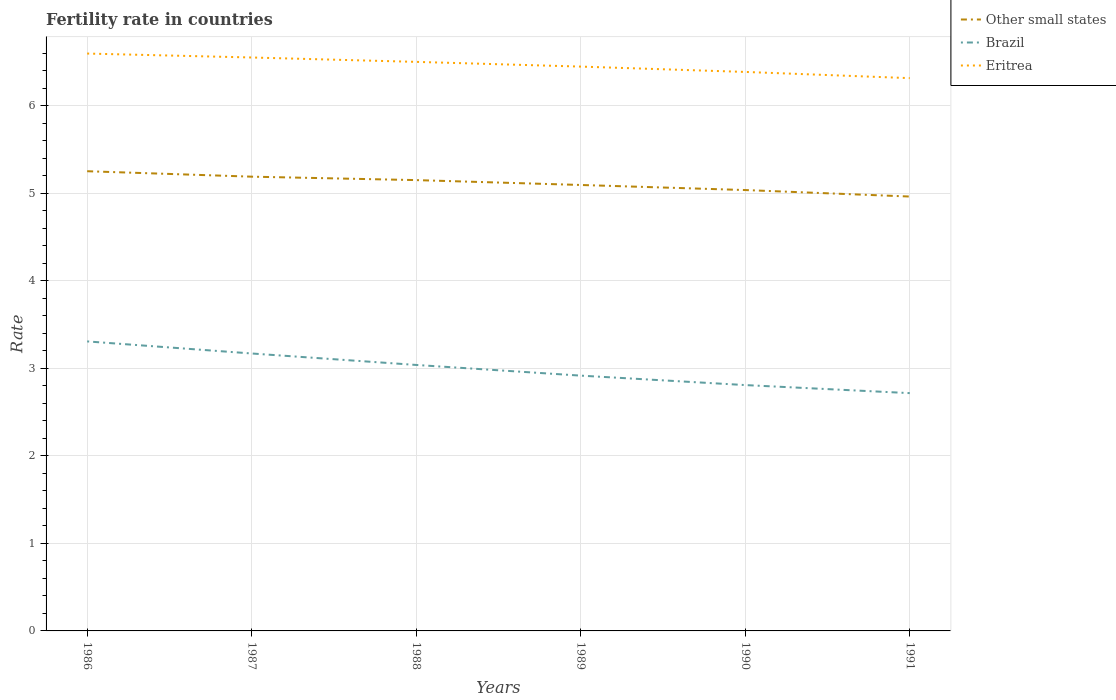Does the line corresponding to Other small states intersect with the line corresponding to Eritrea?
Provide a succinct answer. No. Across all years, what is the maximum fertility rate in Eritrea?
Provide a short and direct response. 6.32. What is the total fertility rate in Eritrea in the graph?
Give a very brief answer. 0.05. What is the difference between the highest and the second highest fertility rate in Brazil?
Your answer should be compact. 0.59. How many lines are there?
Make the answer very short. 3. Does the graph contain grids?
Provide a succinct answer. Yes. How many legend labels are there?
Provide a short and direct response. 3. What is the title of the graph?
Provide a succinct answer. Fertility rate in countries. What is the label or title of the X-axis?
Offer a very short reply. Years. What is the label or title of the Y-axis?
Ensure brevity in your answer.  Rate. What is the Rate of Other small states in 1986?
Ensure brevity in your answer.  5.25. What is the Rate in Brazil in 1986?
Your answer should be very brief. 3.31. What is the Rate in Eritrea in 1986?
Keep it short and to the point. 6.6. What is the Rate of Other small states in 1987?
Your response must be concise. 5.19. What is the Rate in Brazil in 1987?
Provide a succinct answer. 3.17. What is the Rate of Eritrea in 1987?
Offer a terse response. 6.55. What is the Rate of Other small states in 1988?
Offer a terse response. 5.15. What is the Rate of Brazil in 1988?
Offer a very short reply. 3.04. What is the Rate of Eritrea in 1988?
Give a very brief answer. 6.5. What is the Rate in Other small states in 1989?
Your answer should be very brief. 5.1. What is the Rate in Brazil in 1989?
Ensure brevity in your answer.  2.92. What is the Rate in Eritrea in 1989?
Offer a terse response. 6.45. What is the Rate in Other small states in 1990?
Keep it short and to the point. 5.04. What is the Rate of Brazil in 1990?
Give a very brief answer. 2.81. What is the Rate in Eritrea in 1990?
Your response must be concise. 6.39. What is the Rate in Other small states in 1991?
Make the answer very short. 4.96. What is the Rate in Brazil in 1991?
Keep it short and to the point. 2.72. What is the Rate in Eritrea in 1991?
Your answer should be compact. 6.32. Across all years, what is the maximum Rate in Other small states?
Ensure brevity in your answer.  5.25. Across all years, what is the maximum Rate in Brazil?
Your response must be concise. 3.31. Across all years, what is the maximum Rate in Eritrea?
Your answer should be compact. 6.6. Across all years, what is the minimum Rate of Other small states?
Provide a short and direct response. 4.96. Across all years, what is the minimum Rate in Brazil?
Offer a terse response. 2.72. Across all years, what is the minimum Rate in Eritrea?
Provide a short and direct response. 6.32. What is the total Rate in Other small states in the graph?
Your answer should be very brief. 30.69. What is the total Rate in Brazil in the graph?
Your response must be concise. 17.96. What is the total Rate of Eritrea in the graph?
Your answer should be very brief. 38.8. What is the difference between the Rate in Other small states in 1986 and that in 1987?
Your answer should be very brief. 0.06. What is the difference between the Rate of Brazil in 1986 and that in 1987?
Your answer should be very brief. 0.14. What is the difference between the Rate of Eritrea in 1986 and that in 1987?
Offer a very short reply. 0.04. What is the difference between the Rate in Other small states in 1986 and that in 1988?
Offer a very short reply. 0.1. What is the difference between the Rate of Brazil in 1986 and that in 1988?
Give a very brief answer. 0.27. What is the difference between the Rate in Eritrea in 1986 and that in 1988?
Your answer should be compact. 0.1. What is the difference between the Rate of Other small states in 1986 and that in 1989?
Offer a terse response. 0.16. What is the difference between the Rate in Brazil in 1986 and that in 1989?
Provide a succinct answer. 0.39. What is the difference between the Rate in Eritrea in 1986 and that in 1989?
Your response must be concise. 0.15. What is the difference between the Rate of Other small states in 1986 and that in 1990?
Provide a succinct answer. 0.22. What is the difference between the Rate of Brazil in 1986 and that in 1990?
Provide a succinct answer. 0.5. What is the difference between the Rate of Eritrea in 1986 and that in 1990?
Provide a short and direct response. 0.21. What is the difference between the Rate in Other small states in 1986 and that in 1991?
Your answer should be very brief. 0.29. What is the difference between the Rate of Brazil in 1986 and that in 1991?
Your answer should be compact. 0.59. What is the difference between the Rate of Eritrea in 1986 and that in 1991?
Your answer should be compact. 0.28. What is the difference between the Rate in Other small states in 1987 and that in 1988?
Provide a succinct answer. 0.04. What is the difference between the Rate of Brazil in 1987 and that in 1988?
Your response must be concise. 0.13. What is the difference between the Rate of Other small states in 1987 and that in 1989?
Keep it short and to the point. 0.09. What is the difference between the Rate in Brazil in 1987 and that in 1989?
Offer a terse response. 0.25. What is the difference between the Rate in Eritrea in 1987 and that in 1989?
Ensure brevity in your answer.  0.1. What is the difference between the Rate in Other small states in 1987 and that in 1990?
Make the answer very short. 0.15. What is the difference between the Rate of Brazil in 1987 and that in 1990?
Give a very brief answer. 0.36. What is the difference between the Rate of Eritrea in 1987 and that in 1990?
Your answer should be compact. 0.17. What is the difference between the Rate in Other small states in 1987 and that in 1991?
Provide a short and direct response. 0.23. What is the difference between the Rate of Brazil in 1987 and that in 1991?
Provide a short and direct response. 0.45. What is the difference between the Rate of Eritrea in 1987 and that in 1991?
Your response must be concise. 0.24. What is the difference between the Rate of Other small states in 1988 and that in 1989?
Your answer should be compact. 0.06. What is the difference between the Rate in Brazil in 1988 and that in 1989?
Your response must be concise. 0.12. What is the difference between the Rate in Eritrea in 1988 and that in 1989?
Give a very brief answer. 0.05. What is the difference between the Rate of Other small states in 1988 and that in 1990?
Your response must be concise. 0.11. What is the difference between the Rate of Brazil in 1988 and that in 1990?
Give a very brief answer. 0.23. What is the difference between the Rate of Eritrea in 1988 and that in 1990?
Give a very brief answer. 0.12. What is the difference between the Rate in Other small states in 1988 and that in 1991?
Give a very brief answer. 0.19. What is the difference between the Rate of Brazil in 1988 and that in 1991?
Offer a terse response. 0.32. What is the difference between the Rate of Eritrea in 1988 and that in 1991?
Give a very brief answer. 0.19. What is the difference between the Rate of Other small states in 1989 and that in 1990?
Provide a succinct answer. 0.06. What is the difference between the Rate of Brazil in 1989 and that in 1990?
Provide a succinct answer. 0.11. What is the difference between the Rate in Eritrea in 1989 and that in 1990?
Your answer should be very brief. 0.06. What is the difference between the Rate in Other small states in 1989 and that in 1991?
Offer a very short reply. 0.13. What is the difference between the Rate in Brazil in 1989 and that in 1991?
Offer a very short reply. 0.2. What is the difference between the Rate in Eritrea in 1989 and that in 1991?
Your answer should be very brief. 0.13. What is the difference between the Rate in Other small states in 1990 and that in 1991?
Your answer should be very brief. 0.07. What is the difference between the Rate in Brazil in 1990 and that in 1991?
Ensure brevity in your answer.  0.09. What is the difference between the Rate of Eritrea in 1990 and that in 1991?
Your answer should be very brief. 0.07. What is the difference between the Rate in Other small states in 1986 and the Rate in Brazil in 1987?
Make the answer very short. 2.08. What is the difference between the Rate of Other small states in 1986 and the Rate of Eritrea in 1987?
Provide a short and direct response. -1.3. What is the difference between the Rate in Brazil in 1986 and the Rate in Eritrea in 1987?
Your answer should be very brief. -3.24. What is the difference between the Rate of Other small states in 1986 and the Rate of Brazil in 1988?
Make the answer very short. 2.21. What is the difference between the Rate in Other small states in 1986 and the Rate in Eritrea in 1988?
Offer a terse response. -1.25. What is the difference between the Rate of Brazil in 1986 and the Rate of Eritrea in 1988?
Keep it short and to the point. -3.19. What is the difference between the Rate in Other small states in 1986 and the Rate in Brazil in 1989?
Your response must be concise. 2.34. What is the difference between the Rate of Other small states in 1986 and the Rate of Eritrea in 1989?
Your answer should be very brief. -1.2. What is the difference between the Rate of Brazil in 1986 and the Rate of Eritrea in 1989?
Your answer should be compact. -3.14. What is the difference between the Rate in Other small states in 1986 and the Rate in Brazil in 1990?
Your answer should be very brief. 2.44. What is the difference between the Rate in Other small states in 1986 and the Rate in Eritrea in 1990?
Your answer should be very brief. -1.13. What is the difference between the Rate of Brazil in 1986 and the Rate of Eritrea in 1990?
Provide a succinct answer. -3.08. What is the difference between the Rate in Other small states in 1986 and the Rate in Brazil in 1991?
Provide a succinct answer. 2.54. What is the difference between the Rate of Other small states in 1986 and the Rate of Eritrea in 1991?
Offer a very short reply. -1.06. What is the difference between the Rate in Brazil in 1986 and the Rate in Eritrea in 1991?
Provide a succinct answer. -3.01. What is the difference between the Rate in Other small states in 1987 and the Rate in Brazil in 1988?
Ensure brevity in your answer.  2.15. What is the difference between the Rate of Other small states in 1987 and the Rate of Eritrea in 1988?
Make the answer very short. -1.31. What is the difference between the Rate of Brazil in 1987 and the Rate of Eritrea in 1988?
Offer a very short reply. -3.33. What is the difference between the Rate in Other small states in 1987 and the Rate in Brazil in 1989?
Give a very brief answer. 2.27. What is the difference between the Rate in Other small states in 1987 and the Rate in Eritrea in 1989?
Ensure brevity in your answer.  -1.26. What is the difference between the Rate in Brazil in 1987 and the Rate in Eritrea in 1989?
Give a very brief answer. -3.28. What is the difference between the Rate of Other small states in 1987 and the Rate of Brazil in 1990?
Your answer should be compact. 2.38. What is the difference between the Rate of Other small states in 1987 and the Rate of Eritrea in 1990?
Provide a short and direct response. -1.2. What is the difference between the Rate in Brazil in 1987 and the Rate in Eritrea in 1990?
Offer a terse response. -3.22. What is the difference between the Rate in Other small states in 1987 and the Rate in Brazil in 1991?
Your answer should be very brief. 2.47. What is the difference between the Rate of Other small states in 1987 and the Rate of Eritrea in 1991?
Provide a short and direct response. -1.13. What is the difference between the Rate in Brazil in 1987 and the Rate in Eritrea in 1991?
Keep it short and to the point. -3.15. What is the difference between the Rate in Other small states in 1988 and the Rate in Brazil in 1989?
Give a very brief answer. 2.23. What is the difference between the Rate of Other small states in 1988 and the Rate of Eritrea in 1989?
Your answer should be very brief. -1.3. What is the difference between the Rate of Brazil in 1988 and the Rate of Eritrea in 1989?
Provide a short and direct response. -3.41. What is the difference between the Rate in Other small states in 1988 and the Rate in Brazil in 1990?
Provide a succinct answer. 2.34. What is the difference between the Rate in Other small states in 1988 and the Rate in Eritrea in 1990?
Offer a terse response. -1.24. What is the difference between the Rate of Brazil in 1988 and the Rate of Eritrea in 1990?
Provide a succinct answer. -3.35. What is the difference between the Rate of Other small states in 1988 and the Rate of Brazil in 1991?
Ensure brevity in your answer.  2.43. What is the difference between the Rate of Other small states in 1988 and the Rate of Eritrea in 1991?
Offer a terse response. -1.17. What is the difference between the Rate in Brazil in 1988 and the Rate in Eritrea in 1991?
Provide a succinct answer. -3.28. What is the difference between the Rate in Other small states in 1989 and the Rate in Brazil in 1990?
Ensure brevity in your answer.  2.29. What is the difference between the Rate of Other small states in 1989 and the Rate of Eritrea in 1990?
Offer a terse response. -1.29. What is the difference between the Rate of Brazil in 1989 and the Rate of Eritrea in 1990?
Provide a short and direct response. -3.47. What is the difference between the Rate in Other small states in 1989 and the Rate in Brazil in 1991?
Your answer should be very brief. 2.38. What is the difference between the Rate in Other small states in 1989 and the Rate in Eritrea in 1991?
Your answer should be compact. -1.22. What is the difference between the Rate in Brazil in 1989 and the Rate in Eritrea in 1991?
Ensure brevity in your answer.  -3.4. What is the difference between the Rate in Other small states in 1990 and the Rate in Brazil in 1991?
Your response must be concise. 2.32. What is the difference between the Rate of Other small states in 1990 and the Rate of Eritrea in 1991?
Offer a very short reply. -1.28. What is the difference between the Rate in Brazil in 1990 and the Rate in Eritrea in 1991?
Ensure brevity in your answer.  -3.51. What is the average Rate of Other small states per year?
Offer a terse response. 5.12. What is the average Rate in Brazil per year?
Offer a terse response. 2.99. What is the average Rate of Eritrea per year?
Provide a succinct answer. 6.47. In the year 1986, what is the difference between the Rate of Other small states and Rate of Brazil?
Keep it short and to the point. 1.94. In the year 1986, what is the difference between the Rate in Other small states and Rate in Eritrea?
Your response must be concise. -1.34. In the year 1986, what is the difference between the Rate in Brazil and Rate in Eritrea?
Make the answer very short. -3.29. In the year 1987, what is the difference between the Rate in Other small states and Rate in Brazil?
Provide a short and direct response. 2.02. In the year 1987, what is the difference between the Rate in Other small states and Rate in Eritrea?
Provide a succinct answer. -1.36. In the year 1987, what is the difference between the Rate of Brazil and Rate of Eritrea?
Provide a short and direct response. -3.38. In the year 1988, what is the difference between the Rate of Other small states and Rate of Brazil?
Provide a short and direct response. 2.11. In the year 1988, what is the difference between the Rate of Other small states and Rate of Eritrea?
Keep it short and to the point. -1.35. In the year 1988, what is the difference between the Rate in Brazil and Rate in Eritrea?
Offer a terse response. -3.46. In the year 1989, what is the difference between the Rate of Other small states and Rate of Brazil?
Keep it short and to the point. 2.18. In the year 1989, what is the difference between the Rate of Other small states and Rate of Eritrea?
Ensure brevity in your answer.  -1.35. In the year 1989, what is the difference between the Rate of Brazil and Rate of Eritrea?
Ensure brevity in your answer.  -3.53. In the year 1990, what is the difference between the Rate of Other small states and Rate of Brazil?
Give a very brief answer. 2.23. In the year 1990, what is the difference between the Rate of Other small states and Rate of Eritrea?
Make the answer very short. -1.35. In the year 1990, what is the difference between the Rate in Brazil and Rate in Eritrea?
Your answer should be compact. -3.58. In the year 1991, what is the difference between the Rate of Other small states and Rate of Brazil?
Your answer should be very brief. 2.25. In the year 1991, what is the difference between the Rate of Other small states and Rate of Eritrea?
Your answer should be compact. -1.35. In the year 1991, what is the difference between the Rate in Brazil and Rate in Eritrea?
Give a very brief answer. -3.6. What is the ratio of the Rate of Other small states in 1986 to that in 1987?
Offer a very short reply. 1.01. What is the ratio of the Rate in Brazil in 1986 to that in 1987?
Your response must be concise. 1.04. What is the ratio of the Rate in Other small states in 1986 to that in 1988?
Ensure brevity in your answer.  1.02. What is the ratio of the Rate of Brazil in 1986 to that in 1988?
Give a very brief answer. 1.09. What is the ratio of the Rate of Eritrea in 1986 to that in 1988?
Make the answer very short. 1.01. What is the ratio of the Rate in Other small states in 1986 to that in 1989?
Your answer should be very brief. 1.03. What is the ratio of the Rate in Brazil in 1986 to that in 1989?
Your response must be concise. 1.13. What is the ratio of the Rate in Eritrea in 1986 to that in 1989?
Provide a succinct answer. 1.02. What is the ratio of the Rate of Other small states in 1986 to that in 1990?
Provide a succinct answer. 1.04. What is the ratio of the Rate of Brazil in 1986 to that in 1990?
Give a very brief answer. 1.18. What is the ratio of the Rate of Eritrea in 1986 to that in 1990?
Offer a very short reply. 1.03. What is the ratio of the Rate of Other small states in 1986 to that in 1991?
Your response must be concise. 1.06. What is the ratio of the Rate of Brazil in 1986 to that in 1991?
Your response must be concise. 1.22. What is the ratio of the Rate in Eritrea in 1986 to that in 1991?
Provide a short and direct response. 1.04. What is the ratio of the Rate of Other small states in 1987 to that in 1988?
Offer a terse response. 1.01. What is the ratio of the Rate of Brazil in 1987 to that in 1988?
Ensure brevity in your answer.  1.04. What is the ratio of the Rate in Eritrea in 1987 to that in 1988?
Keep it short and to the point. 1.01. What is the ratio of the Rate of Other small states in 1987 to that in 1989?
Ensure brevity in your answer.  1.02. What is the ratio of the Rate of Brazil in 1987 to that in 1989?
Your response must be concise. 1.09. What is the ratio of the Rate in Eritrea in 1987 to that in 1989?
Ensure brevity in your answer.  1.02. What is the ratio of the Rate in Other small states in 1987 to that in 1990?
Your answer should be compact. 1.03. What is the ratio of the Rate of Brazil in 1987 to that in 1990?
Your answer should be compact. 1.13. What is the ratio of the Rate of Eritrea in 1987 to that in 1990?
Provide a succinct answer. 1.03. What is the ratio of the Rate of Other small states in 1987 to that in 1991?
Your answer should be very brief. 1.05. What is the ratio of the Rate of Eritrea in 1987 to that in 1991?
Provide a short and direct response. 1.04. What is the ratio of the Rate of Other small states in 1988 to that in 1989?
Your response must be concise. 1.01. What is the ratio of the Rate in Brazil in 1988 to that in 1989?
Your response must be concise. 1.04. What is the ratio of the Rate in Eritrea in 1988 to that in 1989?
Your response must be concise. 1.01. What is the ratio of the Rate in Other small states in 1988 to that in 1990?
Your response must be concise. 1.02. What is the ratio of the Rate in Brazil in 1988 to that in 1990?
Your answer should be compact. 1.08. What is the ratio of the Rate in Eritrea in 1988 to that in 1990?
Ensure brevity in your answer.  1.02. What is the ratio of the Rate in Other small states in 1988 to that in 1991?
Provide a short and direct response. 1.04. What is the ratio of the Rate of Brazil in 1988 to that in 1991?
Your answer should be compact. 1.12. What is the ratio of the Rate in Eritrea in 1988 to that in 1991?
Give a very brief answer. 1.03. What is the ratio of the Rate in Other small states in 1989 to that in 1990?
Offer a terse response. 1.01. What is the ratio of the Rate of Brazil in 1989 to that in 1990?
Give a very brief answer. 1.04. What is the ratio of the Rate of Eritrea in 1989 to that in 1990?
Provide a short and direct response. 1.01. What is the ratio of the Rate of Other small states in 1989 to that in 1991?
Your response must be concise. 1.03. What is the ratio of the Rate of Brazil in 1989 to that in 1991?
Give a very brief answer. 1.07. What is the ratio of the Rate in Eritrea in 1989 to that in 1991?
Ensure brevity in your answer.  1.02. What is the ratio of the Rate in Other small states in 1990 to that in 1991?
Your answer should be compact. 1.01. What is the ratio of the Rate of Brazil in 1990 to that in 1991?
Your answer should be very brief. 1.03. What is the ratio of the Rate in Eritrea in 1990 to that in 1991?
Make the answer very short. 1.01. What is the difference between the highest and the second highest Rate of Other small states?
Your answer should be very brief. 0.06. What is the difference between the highest and the second highest Rate in Brazil?
Your response must be concise. 0.14. What is the difference between the highest and the second highest Rate in Eritrea?
Your answer should be compact. 0.04. What is the difference between the highest and the lowest Rate of Other small states?
Provide a short and direct response. 0.29. What is the difference between the highest and the lowest Rate of Brazil?
Your answer should be compact. 0.59. What is the difference between the highest and the lowest Rate of Eritrea?
Your answer should be very brief. 0.28. 